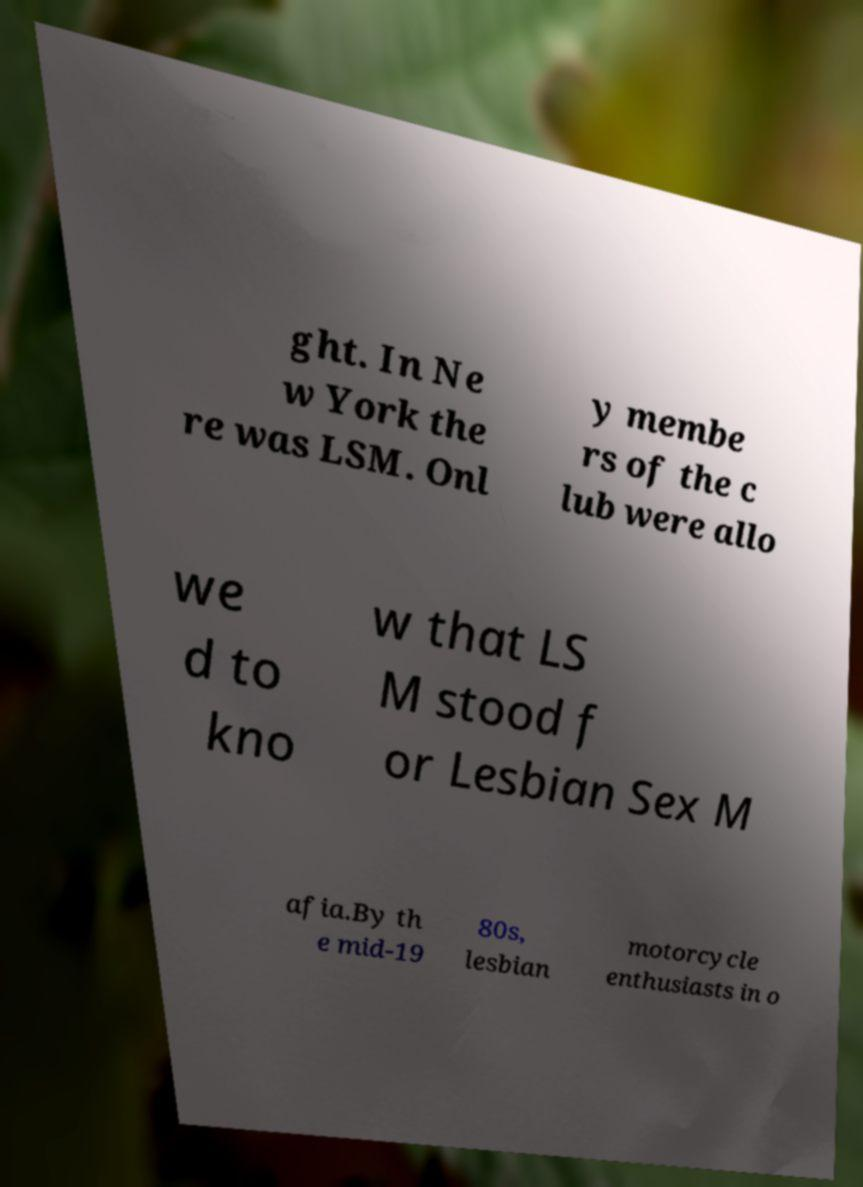For documentation purposes, I need the text within this image transcribed. Could you provide that? ght. In Ne w York the re was LSM. Onl y membe rs of the c lub were allo we d to kno w that LS M stood f or Lesbian Sex M afia.By th e mid-19 80s, lesbian motorcycle enthusiasts in o 